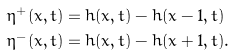<formula> <loc_0><loc_0><loc_500><loc_500>\eta ^ { + } ( x , t ) & = h ( x , t ) - h ( x - 1 , t ) \\ \eta ^ { - } ( x , t ) & = h ( x , t ) - h ( x + 1 , t ) .</formula> 